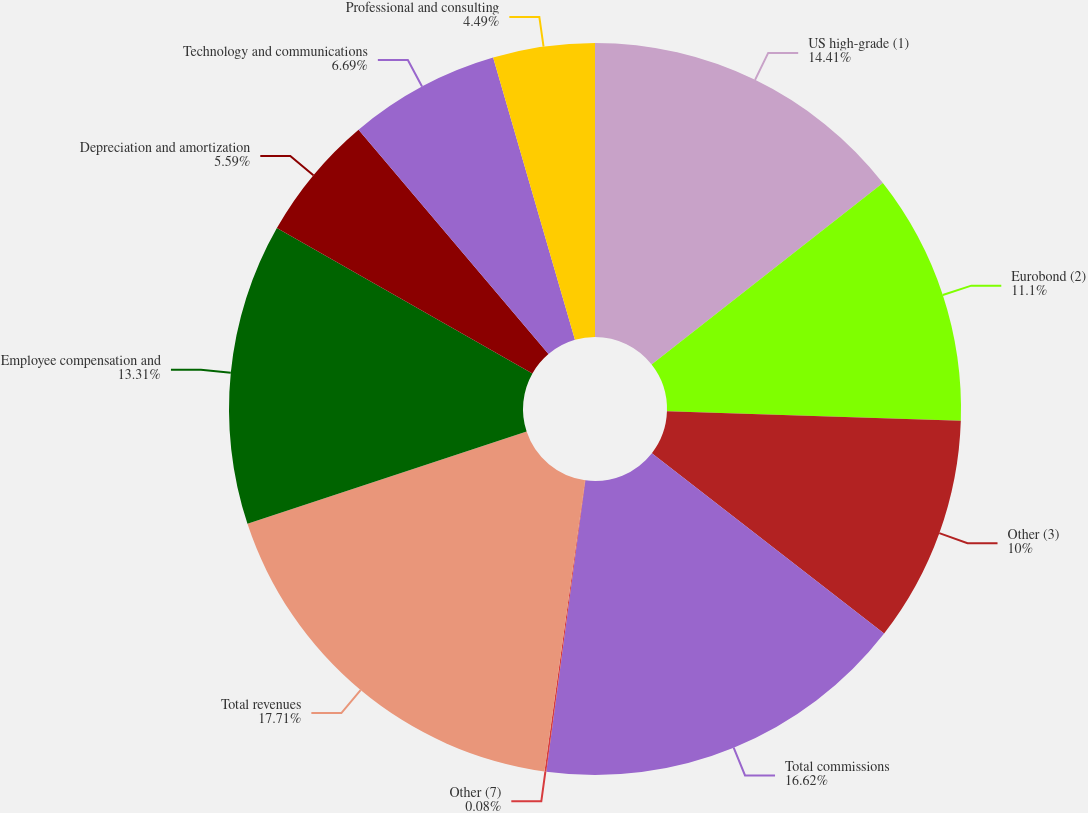Convert chart to OTSL. <chart><loc_0><loc_0><loc_500><loc_500><pie_chart><fcel>US high-grade (1)<fcel>Eurobond (2)<fcel>Other (3)<fcel>Total commissions<fcel>Other (7)<fcel>Total revenues<fcel>Employee compensation and<fcel>Depreciation and amortization<fcel>Technology and communications<fcel>Professional and consulting<nl><fcel>14.41%<fcel>11.1%<fcel>10.0%<fcel>16.62%<fcel>0.08%<fcel>17.72%<fcel>13.31%<fcel>5.59%<fcel>6.69%<fcel>4.49%<nl></chart> 